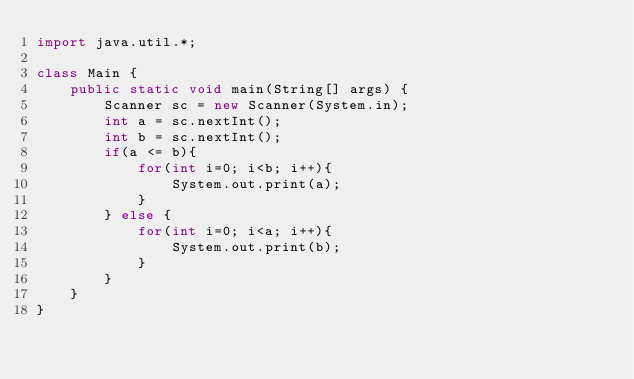<code> <loc_0><loc_0><loc_500><loc_500><_Java_>import java.util.*;

class Main {
    public static void main(String[] args) {
        Scanner sc = new Scanner(System.in);
        int a = sc.nextInt();
        int b = sc.nextInt();
        if(a <= b){
            for(int i=0; i<b; i++){
                System.out.print(a);
            }
        } else {
            for(int i=0; i<a; i++){
                System.out.print(b);
            }
        }
    }
}</code> 